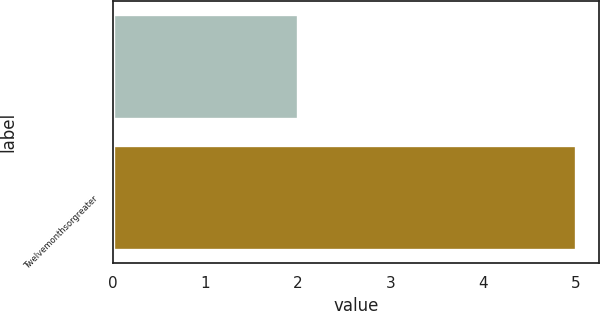Convert chart. <chart><loc_0><loc_0><loc_500><loc_500><bar_chart><ecel><fcel>Twelvemonthsorgreater<nl><fcel>2<fcel>5<nl></chart> 